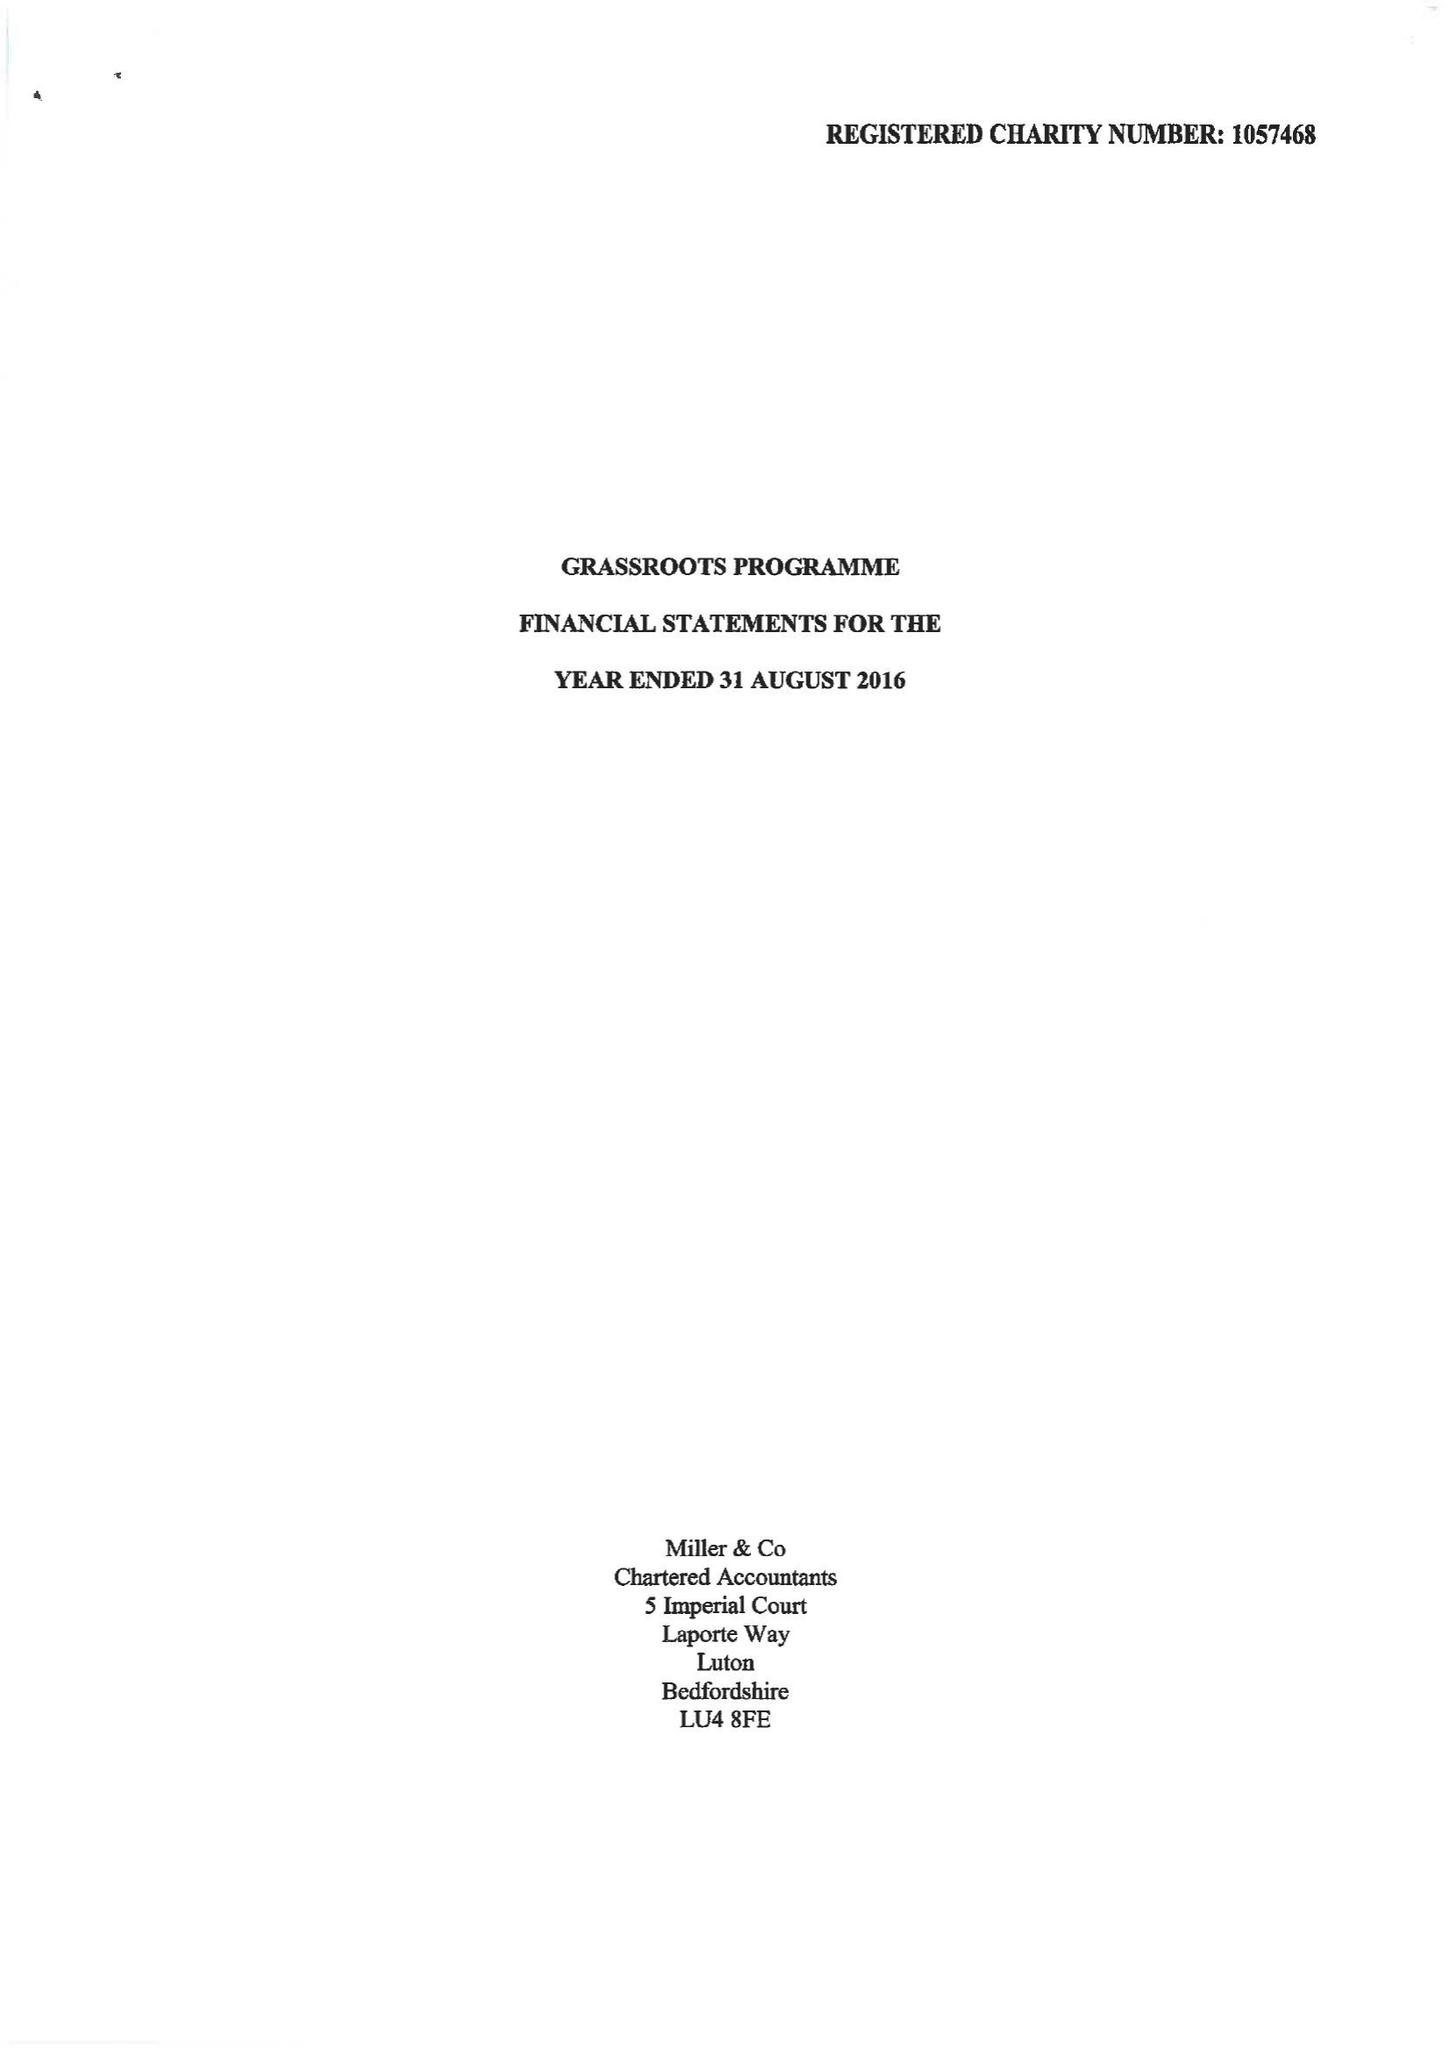What is the value for the spending_annually_in_british_pounds?
Answer the question using a single word or phrase. 127048.00 